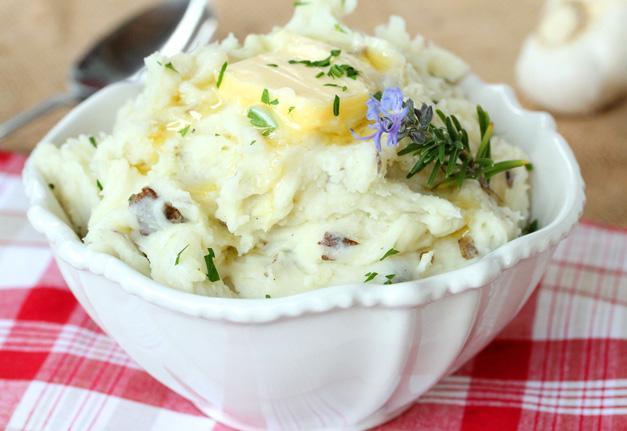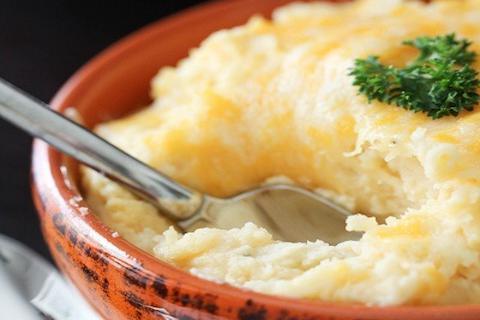The first image is the image on the left, the second image is the image on the right. Considering the images on both sides, is "The right image contains a bowl of mashed potatoes with a spoon handle sticking out of  it." valid? Answer yes or no. Yes. The first image is the image on the left, the second image is the image on the right. Evaluate the accuracy of this statement regarding the images: "The right image shows mashed potatoes served in a bright red bowl, and no image shows a green garnish sprig on top of mashed potatoes.". Is it true? Answer yes or no. No. 